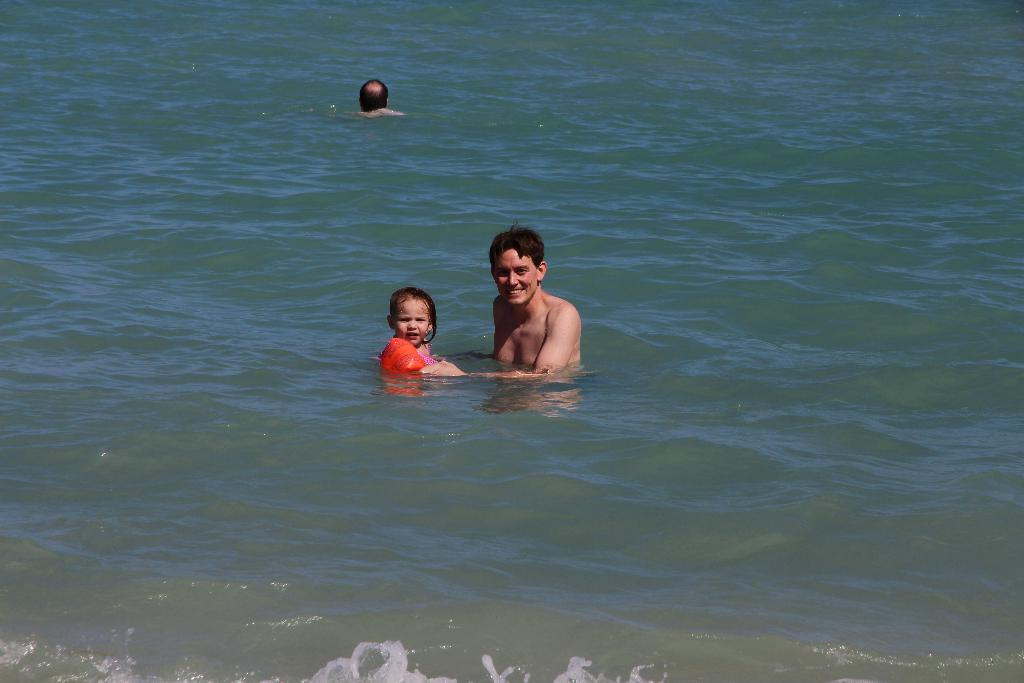What is visible in the image? There is water visible in the image. Can you describe the people in the image? There is a child wearing an orange dress and two other persons in the water. What type of news can be heard coming from the hydrant in the image? There is no hydrant present in the image, and therefore no news can be heard from it. 